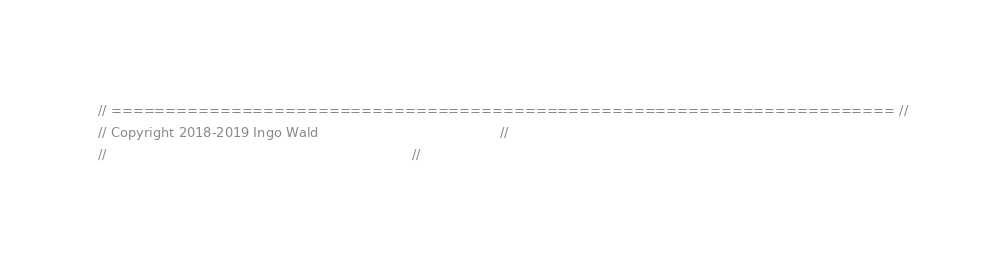Convert code to text. <code><loc_0><loc_0><loc_500><loc_500><_Cuda_>// ======================================================================== //
// Copyright 2018-2019 Ingo Wald                                            //
//                                                                          //</code> 